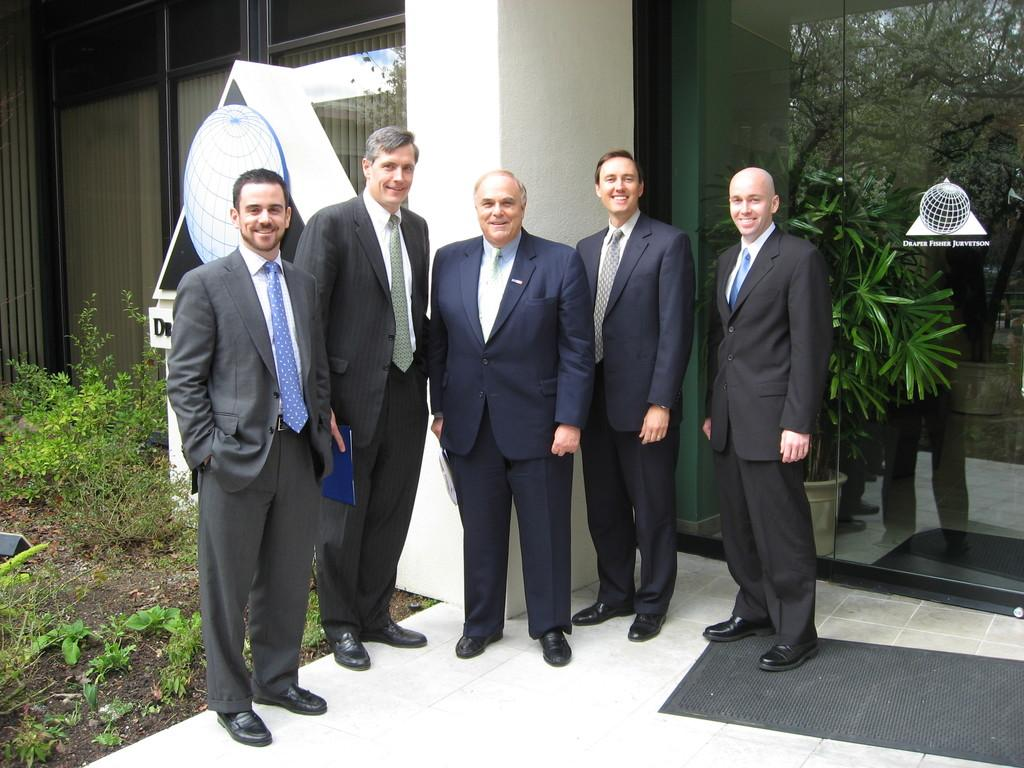How many people are in the image? There is a group of people in the image. What are the people wearing in the image? The people are wearing formal costumes. What are the people doing in the image? The people are standing together. What can be seen in the background of the image? There is a building and a glass wall in the background of the image. What type of vegetation is present in the image? There are plants on the ground in the image. What type of drum can be heard in the image? There is no drum present in the image, and therefore no sound can be heard. How much payment is being exchanged in the image? There is no indication of any payment being exchanged in the image. 